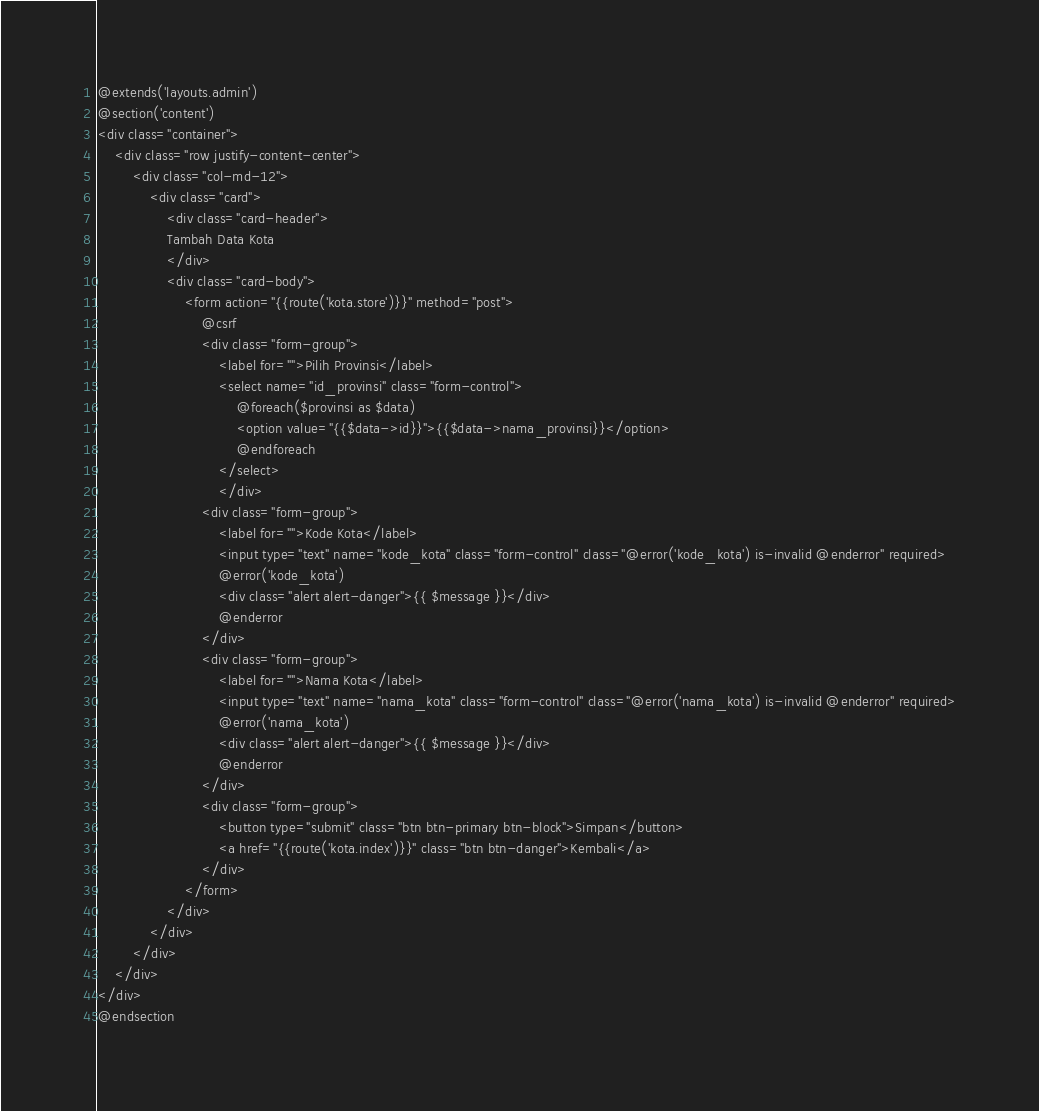Convert code to text. <code><loc_0><loc_0><loc_500><loc_500><_PHP_>@extends('layouts.admin')
@section('content')
<div class="container">
    <div class="row justify-content-center">
        <div class="col-md-12">
            <div class="card">
                <div class="card-header">
                Tambah Data Kota
                </div>
                <div class="card-body">
                    <form action="{{route('kota.store')}}" method="post">
                        @csrf
                        <div class="form-group">
                            <label for="">Pilih Provinsi</label>
                            <select name="id_provinsi" class="form-control">
                                @foreach($provinsi as $data)
                                <option value="{{$data->id}}">{{$data->nama_provinsi}}</option>
                                @endforeach
                            </select>
                            </div>
                        <div class="form-group">
                            <label for="">Kode Kota</label>
                            <input type="text" name="kode_kota" class="form-control" class="@error('kode_kota') is-invalid @enderror" required>
                            @error('kode_kota')
                            <div class="alert alert-danger">{{ $message }}</div>
                            @enderror
                        </div>
                        <div class="form-group">
                            <label for="">Nama Kota</label>
                            <input type="text" name="nama_kota" class="form-control" class="@error('nama_kota') is-invalid @enderror" required>
                            @error('nama_kota')
                            <div class="alert alert-danger">{{ $message }}</div>
                            @enderror
                        </div>
                        <div class="form-group">
                            <button type="submit" class="btn btn-primary btn-block">Simpan</button>
                            <a href="{{route('kota.index')}}" class="btn btn-danger">Kembali</a>
                        </div>
                    </form>
                </div>
            </div>
        </div>
    </div>
</div>
@endsection</code> 